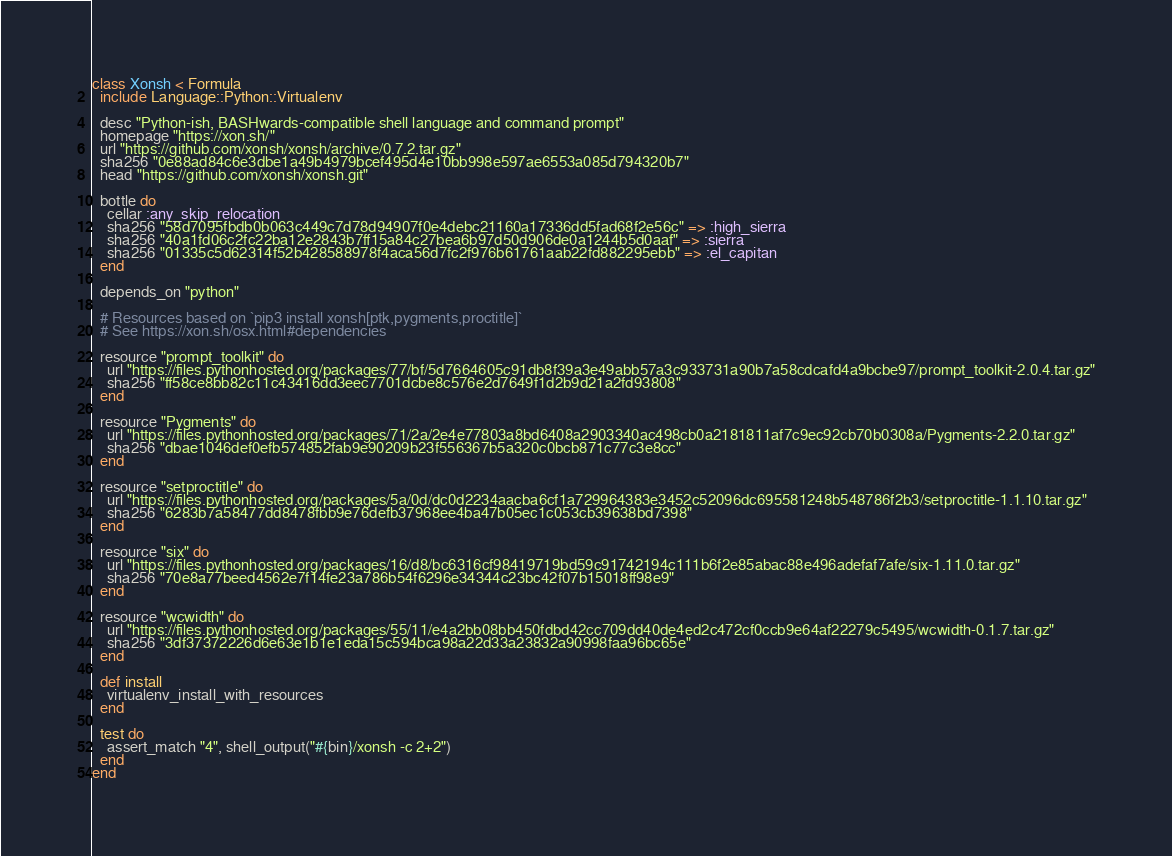<code> <loc_0><loc_0><loc_500><loc_500><_Ruby_>class Xonsh < Formula
  include Language::Python::Virtualenv

  desc "Python-ish, BASHwards-compatible shell language and command prompt"
  homepage "https://xon.sh/"
  url "https://github.com/xonsh/xonsh/archive/0.7.2.tar.gz"
  sha256 "0e88ad84c6e3dbe1a49b4979bcef495d4e10bb998e597ae6553a085d794320b7"
  head "https://github.com/xonsh/xonsh.git"

  bottle do
    cellar :any_skip_relocation
    sha256 "58d7095fbdb0b063c449c7d78d94907f0e4debc21160a17336dd5fad68f2e56c" => :high_sierra
    sha256 "40a1fd06c2fc22ba12e2843b7ff15a84c27bea6b97d50d906de0a1244b5d0aaf" => :sierra
    sha256 "01335c5d62314f52b428588978f4aca56d7fc2f976b61761aab22fd882295ebb" => :el_capitan
  end

  depends_on "python"

  # Resources based on `pip3 install xonsh[ptk,pygments,proctitle]`
  # See https://xon.sh/osx.html#dependencies

  resource "prompt_toolkit" do
    url "https://files.pythonhosted.org/packages/77/bf/5d7664605c91db8f39a3e49abb57a3c933731a90b7a58cdcafd4a9bcbe97/prompt_toolkit-2.0.4.tar.gz"
    sha256 "ff58ce8bb82c11c43416dd3eec7701dcbe8c576e2d7649f1d2b9d21a2fd93808"
  end

  resource "Pygments" do
    url "https://files.pythonhosted.org/packages/71/2a/2e4e77803a8bd6408a2903340ac498cb0a2181811af7c9ec92cb70b0308a/Pygments-2.2.0.tar.gz"
    sha256 "dbae1046def0efb574852fab9e90209b23f556367b5a320c0bcb871c77c3e8cc"
  end

  resource "setproctitle" do
    url "https://files.pythonhosted.org/packages/5a/0d/dc0d2234aacba6cf1a729964383e3452c52096dc695581248b548786f2b3/setproctitle-1.1.10.tar.gz"
    sha256 "6283b7a58477dd8478fbb9e76defb37968ee4ba47b05ec1c053cb39638bd7398"
  end

  resource "six" do
    url "https://files.pythonhosted.org/packages/16/d8/bc6316cf98419719bd59c91742194c111b6f2e85abac88e496adefaf7afe/six-1.11.0.tar.gz"
    sha256 "70e8a77beed4562e7f14fe23a786b54f6296e34344c23bc42f07b15018ff98e9"
  end

  resource "wcwidth" do
    url "https://files.pythonhosted.org/packages/55/11/e4a2bb08bb450fdbd42cc709dd40de4ed2c472cf0ccb9e64af22279c5495/wcwidth-0.1.7.tar.gz"
    sha256 "3df37372226d6e63e1b1e1eda15c594bca98a22d33a23832a90998faa96bc65e"
  end

  def install
    virtualenv_install_with_resources
  end

  test do
    assert_match "4", shell_output("#{bin}/xonsh -c 2+2")
  end
end
</code> 